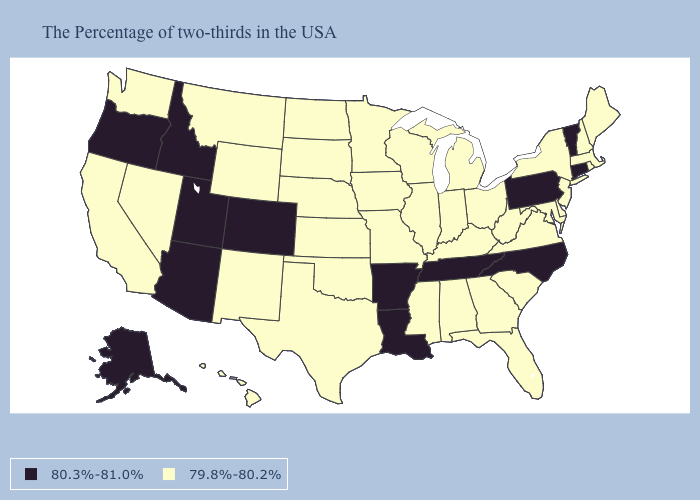Does Alaska have the same value as Tennessee?
Concise answer only. Yes. What is the lowest value in states that border Montana?
Give a very brief answer. 79.8%-80.2%. Name the states that have a value in the range 80.3%-81.0%?
Keep it brief. Vermont, Connecticut, Pennsylvania, North Carolina, Tennessee, Louisiana, Arkansas, Colorado, Utah, Arizona, Idaho, Oregon, Alaska. Is the legend a continuous bar?
Keep it brief. No. Name the states that have a value in the range 79.8%-80.2%?
Concise answer only. Maine, Massachusetts, Rhode Island, New Hampshire, New York, New Jersey, Delaware, Maryland, Virginia, South Carolina, West Virginia, Ohio, Florida, Georgia, Michigan, Kentucky, Indiana, Alabama, Wisconsin, Illinois, Mississippi, Missouri, Minnesota, Iowa, Kansas, Nebraska, Oklahoma, Texas, South Dakota, North Dakota, Wyoming, New Mexico, Montana, Nevada, California, Washington, Hawaii. What is the value of South Carolina?
Short answer required. 79.8%-80.2%. What is the value of Connecticut?
Keep it brief. 80.3%-81.0%. Does New Jersey have a lower value than Florida?
Concise answer only. No. What is the value of Delaware?
Concise answer only. 79.8%-80.2%. Does New York have a higher value than Montana?
Quick response, please. No. Name the states that have a value in the range 80.3%-81.0%?
Concise answer only. Vermont, Connecticut, Pennsylvania, North Carolina, Tennessee, Louisiana, Arkansas, Colorado, Utah, Arizona, Idaho, Oregon, Alaska. What is the lowest value in the West?
Be succinct. 79.8%-80.2%. Name the states that have a value in the range 79.8%-80.2%?
Give a very brief answer. Maine, Massachusetts, Rhode Island, New Hampshire, New York, New Jersey, Delaware, Maryland, Virginia, South Carolina, West Virginia, Ohio, Florida, Georgia, Michigan, Kentucky, Indiana, Alabama, Wisconsin, Illinois, Mississippi, Missouri, Minnesota, Iowa, Kansas, Nebraska, Oklahoma, Texas, South Dakota, North Dakota, Wyoming, New Mexico, Montana, Nevada, California, Washington, Hawaii. Name the states that have a value in the range 80.3%-81.0%?
Answer briefly. Vermont, Connecticut, Pennsylvania, North Carolina, Tennessee, Louisiana, Arkansas, Colorado, Utah, Arizona, Idaho, Oregon, Alaska. 